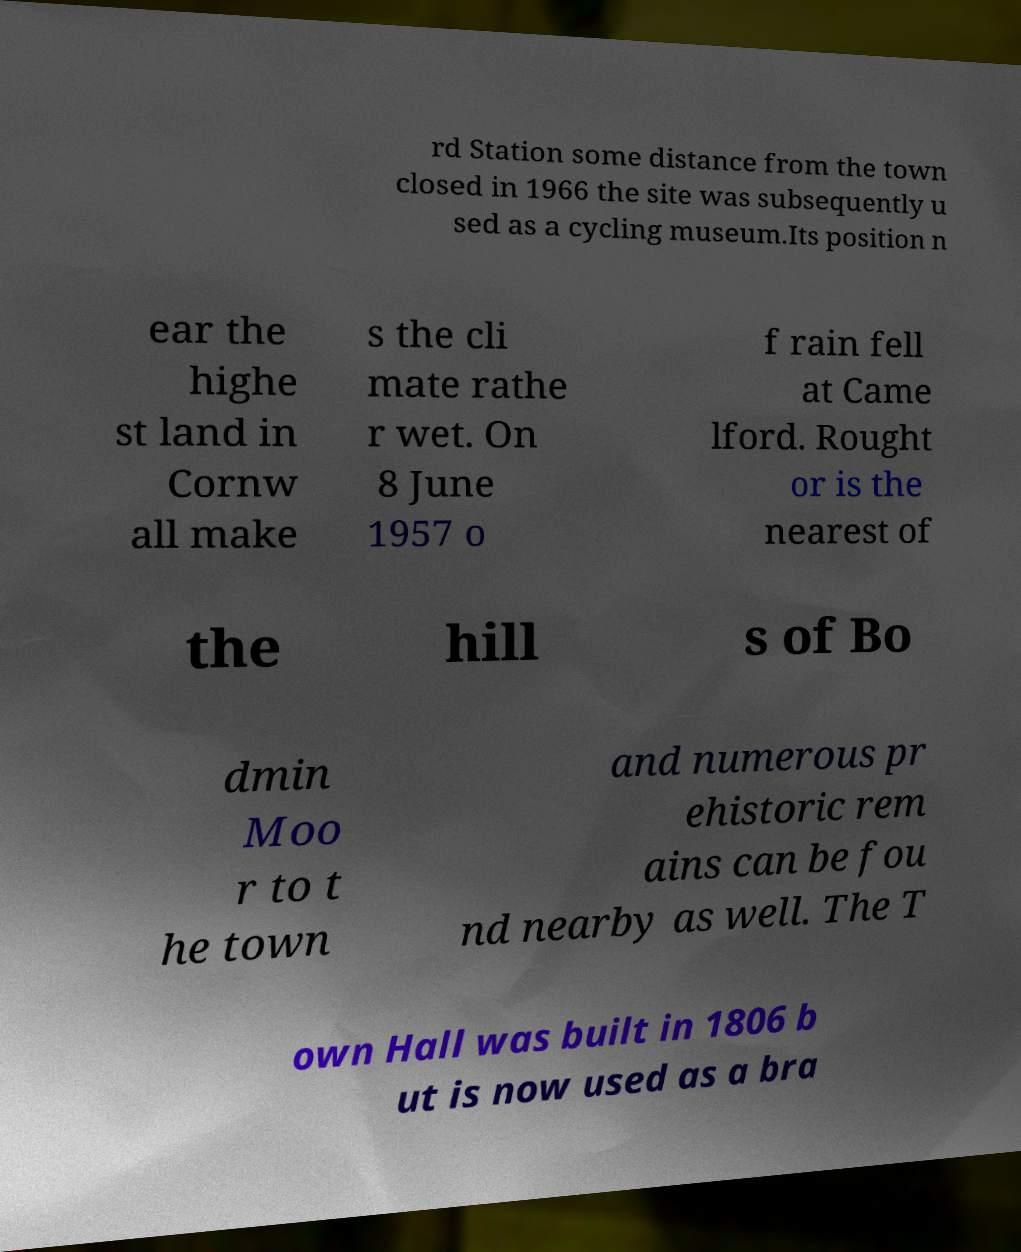Can you accurately transcribe the text from the provided image for me? rd Station some distance from the town closed in 1966 the site was subsequently u sed as a cycling museum.Its position n ear the highe st land in Cornw all make s the cli mate rathe r wet. On 8 June 1957 o f rain fell at Came lford. Rought or is the nearest of the hill s of Bo dmin Moo r to t he town and numerous pr ehistoric rem ains can be fou nd nearby as well. The T own Hall was built in 1806 b ut is now used as a bra 